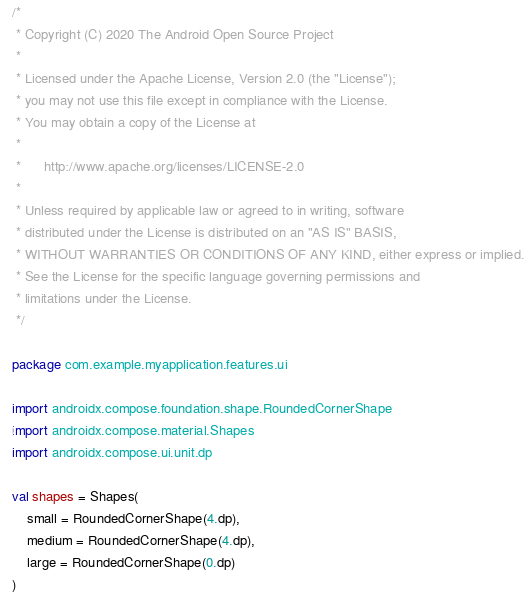Convert code to text. <code><loc_0><loc_0><loc_500><loc_500><_Kotlin_>/*
 * Copyright (C) 2020 The Android Open Source Project
 *
 * Licensed under the Apache License, Version 2.0 (the "License");
 * you may not use this file except in compliance with the License.
 * You may obtain a copy of the License at
 *
 *      http://www.apache.org/licenses/LICENSE-2.0
 *
 * Unless required by applicable law or agreed to in writing, software
 * distributed under the License is distributed on an "AS IS" BASIS,
 * WITHOUT WARRANTIES OR CONDITIONS OF ANY KIND, either express or implied.
 * See the License for the specific language governing permissions and
 * limitations under the License.
 */

package com.example.myapplication.features.ui

import androidx.compose.foundation.shape.RoundedCornerShape
import androidx.compose.material.Shapes
import androidx.compose.ui.unit.dp

val shapes = Shapes(
    small = RoundedCornerShape(4.dp),
    medium = RoundedCornerShape(4.dp),
    large = RoundedCornerShape(0.dp)
)

</code> 